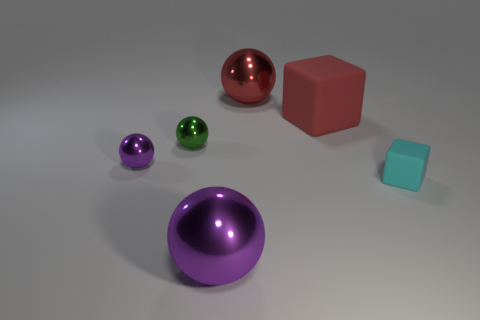Subtract all red cylinders. How many purple balls are left? 2 Subtract all large red spheres. How many spheres are left? 3 Add 3 large red shiny balls. How many objects exist? 9 Subtract all green spheres. How many spheres are left? 3 Subtract all balls. How many objects are left? 2 Subtract all green balls. Subtract all brown blocks. How many balls are left? 3 Subtract 1 cyan cubes. How many objects are left? 5 Subtract all big balls. Subtract all big metallic balls. How many objects are left? 2 Add 5 small shiny spheres. How many small shiny spheres are left? 7 Add 2 blue objects. How many blue objects exist? 2 